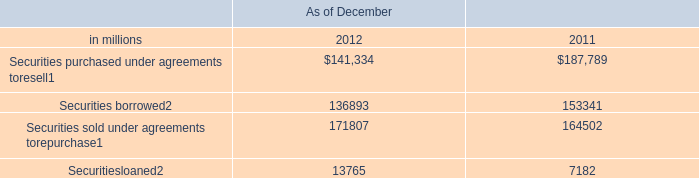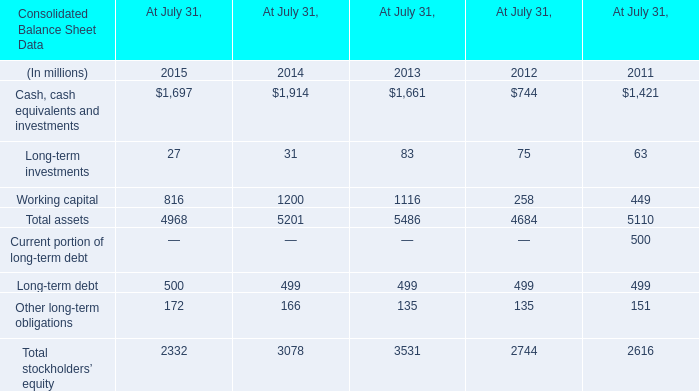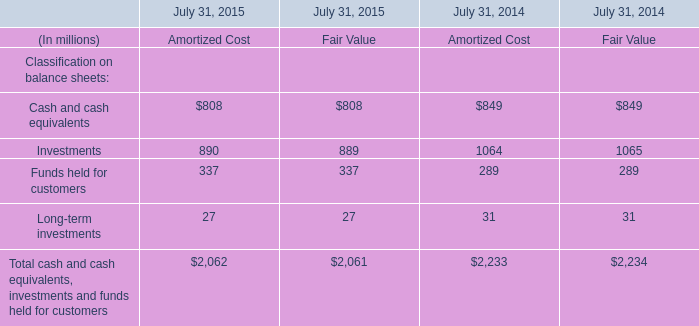What's the average of Securitiesloaned of As of December 2011, and Working capital of At July 31, 2013 ? 
Computations: ((7182.0 + 1116.0) / 2)
Answer: 4149.0. 